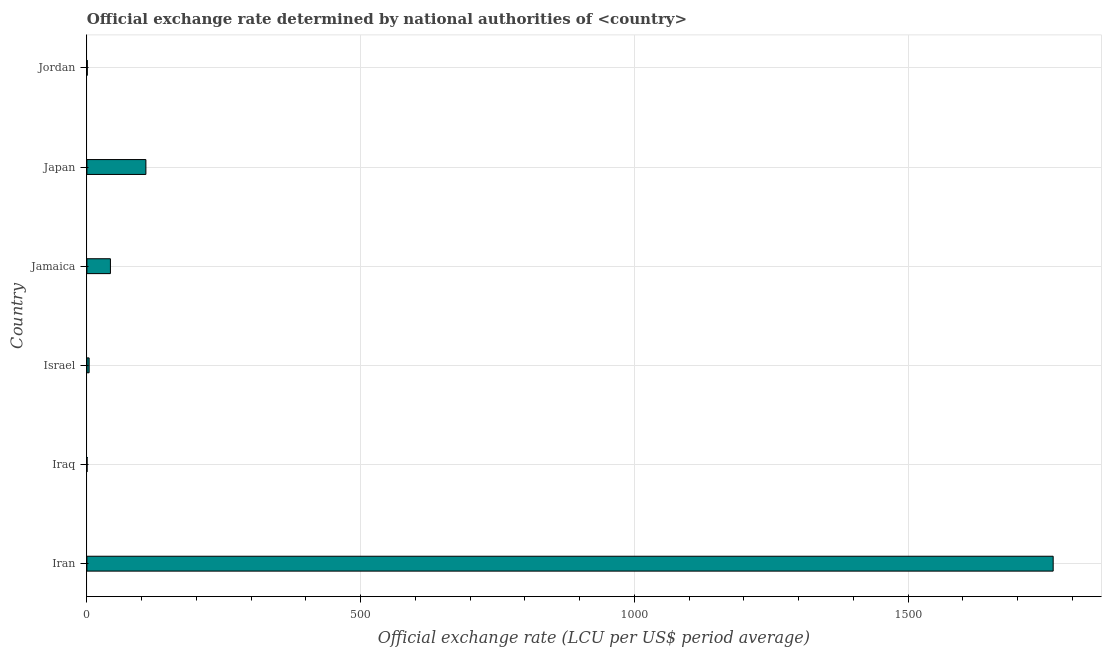Does the graph contain any zero values?
Give a very brief answer. No. What is the title of the graph?
Offer a very short reply. Official exchange rate determined by national authorities of <country>. What is the label or title of the X-axis?
Your response must be concise. Official exchange rate (LCU per US$ period average). What is the official exchange rate in Japan?
Your answer should be compact. 107.77. Across all countries, what is the maximum official exchange rate?
Provide a short and direct response. 1764.97. Across all countries, what is the minimum official exchange rate?
Your answer should be very brief. 0.31. In which country was the official exchange rate maximum?
Your response must be concise. Iran. In which country was the official exchange rate minimum?
Give a very brief answer. Iraq. What is the sum of the official exchange rate?
Provide a succinct answer. 1920.82. What is the difference between the official exchange rate in Israel and Jamaica?
Provide a short and direct response. -38.91. What is the average official exchange rate per country?
Your answer should be very brief. 320.14. What is the median official exchange rate?
Ensure brevity in your answer.  23.53. In how many countries, is the official exchange rate greater than 1400 ?
Ensure brevity in your answer.  1. What is the ratio of the official exchange rate in Iran to that in Jordan?
Your answer should be very brief. 2489.38. Is the official exchange rate in Iraq less than that in Israel?
Give a very brief answer. Yes. What is the difference between the highest and the second highest official exchange rate?
Your response must be concise. 1657.2. Is the sum of the official exchange rate in Israel and Jordan greater than the maximum official exchange rate across all countries?
Provide a short and direct response. No. What is the difference between the highest and the lowest official exchange rate?
Offer a terse response. 1764.66. In how many countries, is the official exchange rate greater than the average official exchange rate taken over all countries?
Offer a terse response. 1. How many bars are there?
Your response must be concise. 6. How many countries are there in the graph?
Your answer should be compact. 6. What is the difference between two consecutive major ticks on the X-axis?
Your answer should be very brief. 500. What is the Official exchange rate (LCU per US$ period average) of Iran?
Make the answer very short. 1764.97. What is the Official exchange rate (LCU per US$ period average) in Iraq?
Your answer should be compact. 0.31. What is the Official exchange rate (LCU per US$ period average) of Israel?
Give a very brief answer. 4.08. What is the Official exchange rate (LCU per US$ period average) in Jamaica?
Your answer should be compact. 42.99. What is the Official exchange rate (LCU per US$ period average) in Japan?
Your answer should be very brief. 107.77. What is the Official exchange rate (LCU per US$ period average) of Jordan?
Your response must be concise. 0.71. What is the difference between the Official exchange rate (LCU per US$ period average) in Iran and Iraq?
Your response must be concise. 1764.66. What is the difference between the Official exchange rate (LCU per US$ period average) in Iran and Israel?
Provide a short and direct response. 1760.89. What is the difference between the Official exchange rate (LCU per US$ period average) in Iran and Jamaica?
Offer a very short reply. 1721.98. What is the difference between the Official exchange rate (LCU per US$ period average) in Iran and Japan?
Make the answer very short. 1657.2. What is the difference between the Official exchange rate (LCU per US$ period average) in Iran and Jordan?
Offer a very short reply. 1764.26. What is the difference between the Official exchange rate (LCU per US$ period average) in Iraq and Israel?
Make the answer very short. -3.77. What is the difference between the Official exchange rate (LCU per US$ period average) in Iraq and Jamaica?
Your answer should be compact. -42.67. What is the difference between the Official exchange rate (LCU per US$ period average) in Iraq and Japan?
Your answer should be very brief. -107.45. What is the difference between the Official exchange rate (LCU per US$ period average) in Iraq and Jordan?
Your response must be concise. -0.4. What is the difference between the Official exchange rate (LCU per US$ period average) in Israel and Jamaica?
Provide a succinct answer. -38.91. What is the difference between the Official exchange rate (LCU per US$ period average) in Israel and Japan?
Your answer should be very brief. -103.69. What is the difference between the Official exchange rate (LCU per US$ period average) in Israel and Jordan?
Keep it short and to the point. 3.37. What is the difference between the Official exchange rate (LCU per US$ period average) in Jamaica and Japan?
Give a very brief answer. -64.78. What is the difference between the Official exchange rate (LCU per US$ period average) in Jamaica and Jordan?
Provide a succinct answer. 42.28. What is the difference between the Official exchange rate (LCU per US$ period average) in Japan and Jordan?
Your answer should be very brief. 107.06. What is the ratio of the Official exchange rate (LCU per US$ period average) in Iran to that in Iraq?
Provide a short and direct response. 5677.74. What is the ratio of the Official exchange rate (LCU per US$ period average) in Iran to that in Israel?
Offer a terse response. 432.87. What is the ratio of the Official exchange rate (LCU per US$ period average) in Iran to that in Jamaica?
Offer a terse response. 41.06. What is the ratio of the Official exchange rate (LCU per US$ period average) in Iran to that in Japan?
Provide a succinct answer. 16.38. What is the ratio of the Official exchange rate (LCU per US$ period average) in Iran to that in Jordan?
Offer a very short reply. 2489.38. What is the ratio of the Official exchange rate (LCU per US$ period average) in Iraq to that in Israel?
Your answer should be compact. 0.08. What is the ratio of the Official exchange rate (LCU per US$ period average) in Iraq to that in Jamaica?
Offer a very short reply. 0.01. What is the ratio of the Official exchange rate (LCU per US$ period average) in Iraq to that in Japan?
Your answer should be compact. 0. What is the ratio of the Official exchange rate (LCU per US$ period average) in Iraq to that in Jordan?
Provide a short and direct response. 0.44. What is the ratio of the Official exchange rate (LCU per US$ period average) in Israel to that in Jamaica?
Offer a terse response. 0.1. What is the ratio of the Official exchange rate (LCU per US$ period average) in Israel to that in Japan?
Your response must be concise. 0.04. What is the ratio of the Official exchange rate (LCU per US$ period average) in Israel to that in Jordan?
Offer a very short reply. 5.75. What is the ratio of the Official exchange rate (LCU per US$ period average) in Jamaica to that in Japan?
Make the answer very short. 0.4. What is the ratio of the Official exchange rate (LCU per US$ period average) in Jamaica to that in Jordan?
Keep it short and to the point. 60.63. What is the ratio of the Official exchange rate (LCU per US$ period average) in Japan to that in Jordan?
Ensure brevity in your answer.  152. 